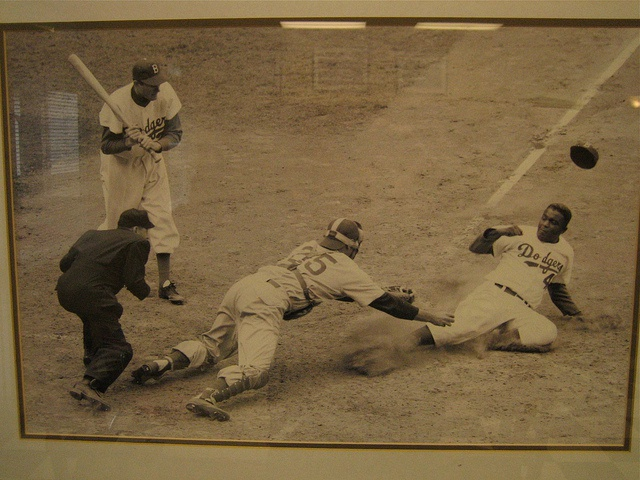Describe the objects in this image and their specific colors. I can see people in gray, tan, olive, and black tones, people in gray, tan, olive, and black tones, people in gray, olive, and black tones, people in gray and black tones, and baseball bat in gray and olive tones in this image. 